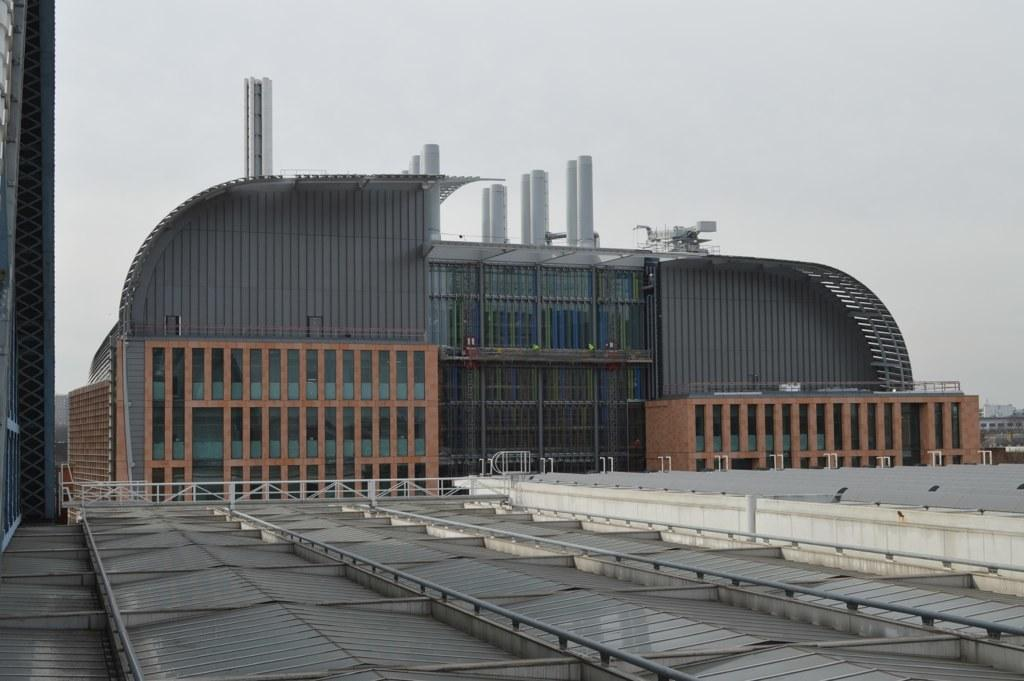What type of structure can be seen in the image? There are railings in the image. What other types of structures are present in the image? There are buildings in the image. What is visible at the top of the image? The sky is visible at the top of the image. Can you see any oranges growing on the railings in the image? There are no oranges or any indication of plant life on the railings in the image. Are there any astronauts visible in the image, considering the mention of space? There is no reference to space or any astronauts in the image; it features railings and buildings. 